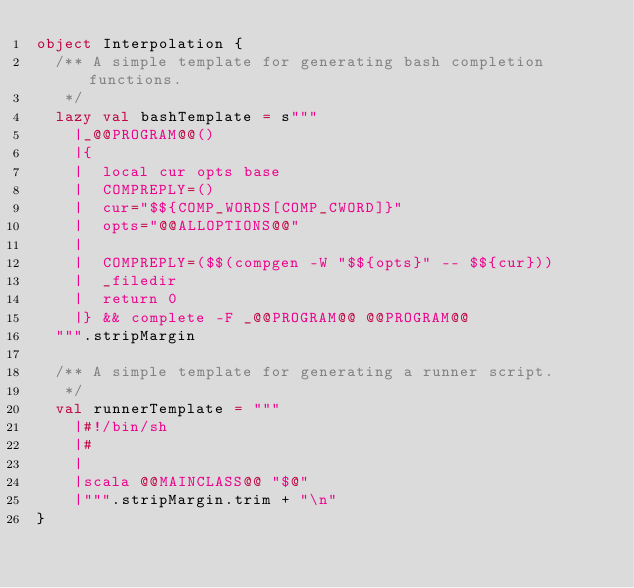<code> <loc_0><loc_0><loc_500><loc_500><_Scala_>object Interpolation {
  /** A simple template for generating bash completion functions.
   */
  lazy val bashTemplate = s"""
    |_@@PROGRAM@@()
    |{
    |  local cur opts base
    |  COMPREPLY=()
    |  cur="$${COMP_WORDS[COMP_CWORD]}"
    |  opts="@@ALLOPTIONS@@"
    |
    |  COMPREPLY=($$(compgen -W "$${opts}" -- $${cur}))
    |  _filedir
    |  return 0
    |} && complete -F _@@PROGRAM@@ @@PROGRAM@@
  """.stripMargin

  /** A simple template for generating a runner script.
   */
  val runnerTemplate = """
    |#!/bin/sh
    |#
    |
    |scala @@MAINCLASS@@ "$@"
    |""".stripMargin.trim + "\n"
}
</code> 